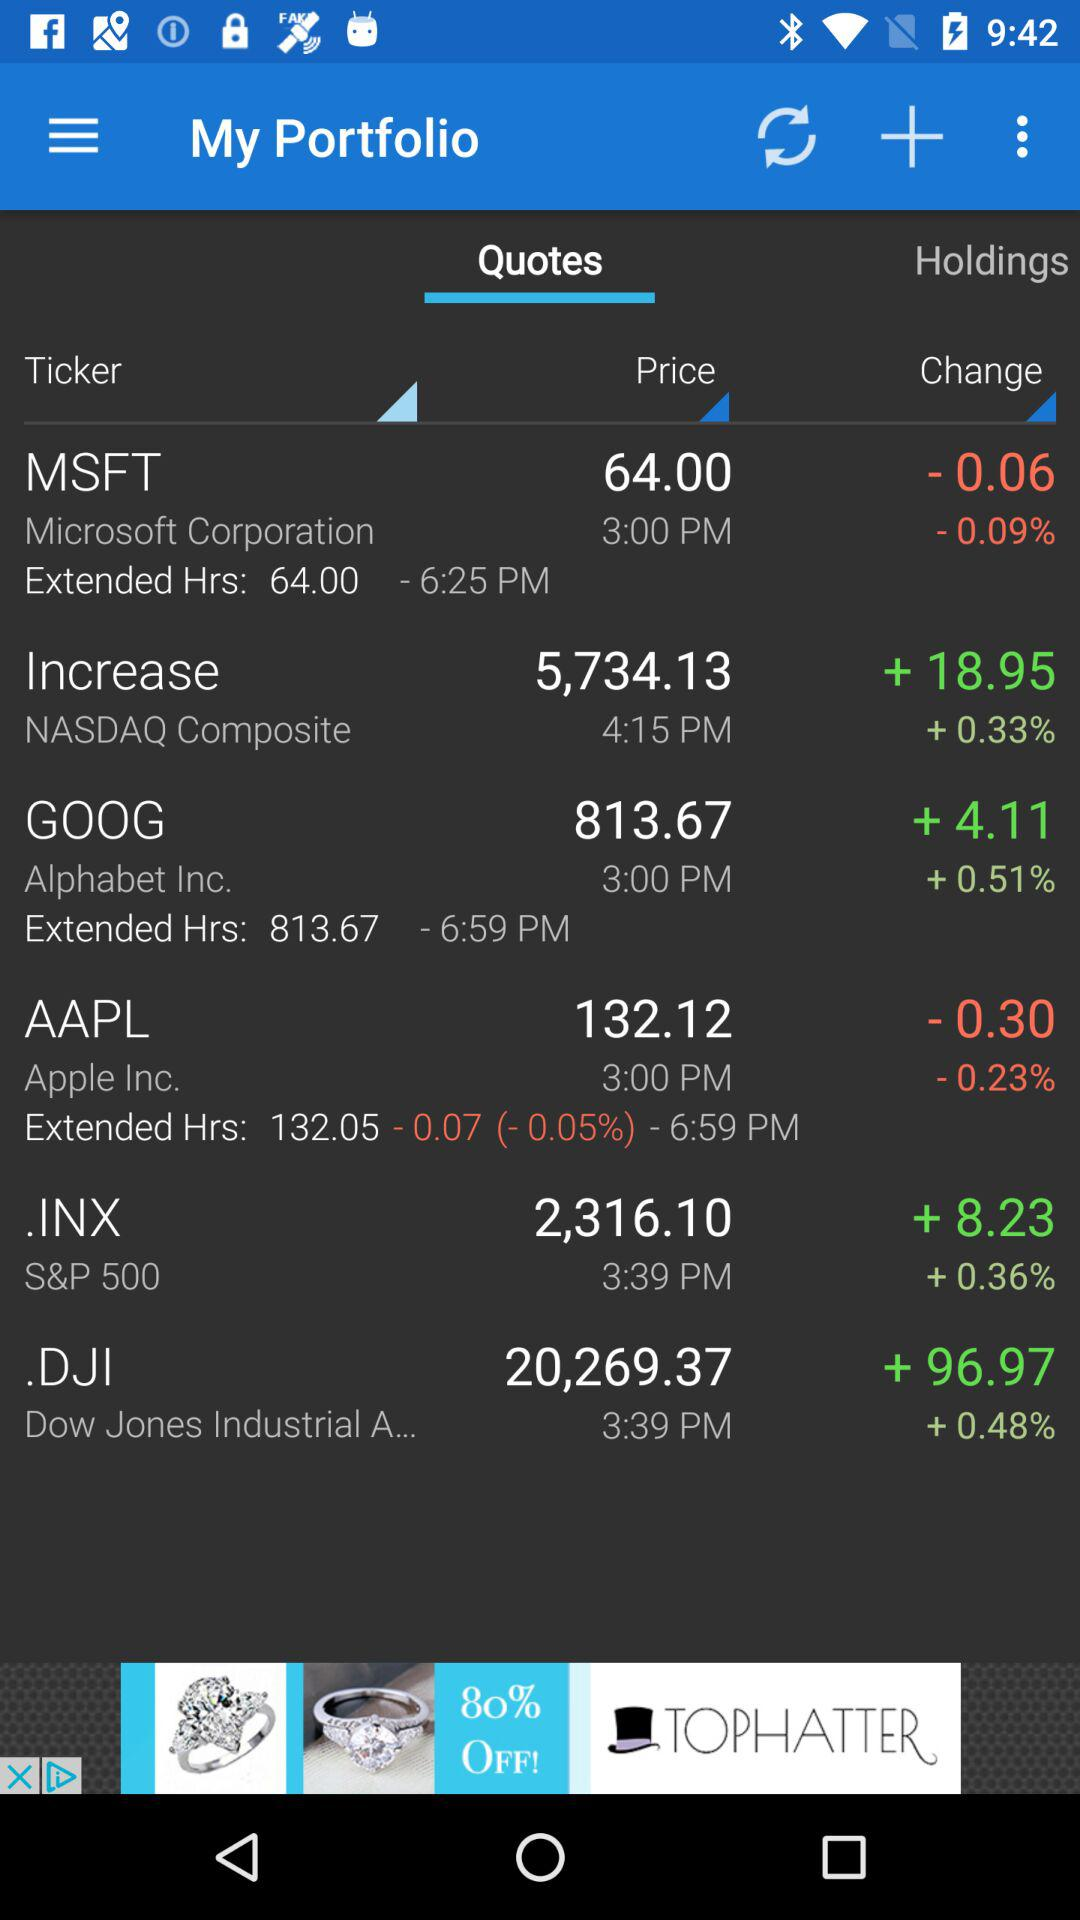What is the change in price for Microsoft Corporation?
Answer the question using a single word or phrase. -0.06 